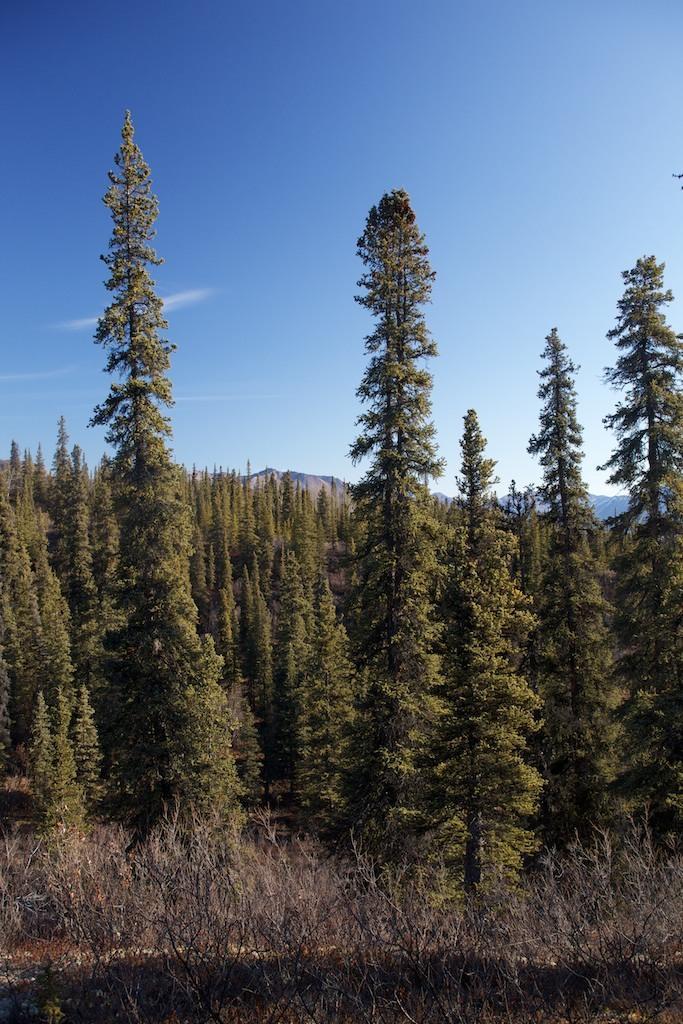In one or two sentences, can you explain what this image depicts? In the center of the image there are trees. At the bottom of the image there are dry plants. At the top of the image there is sky. 